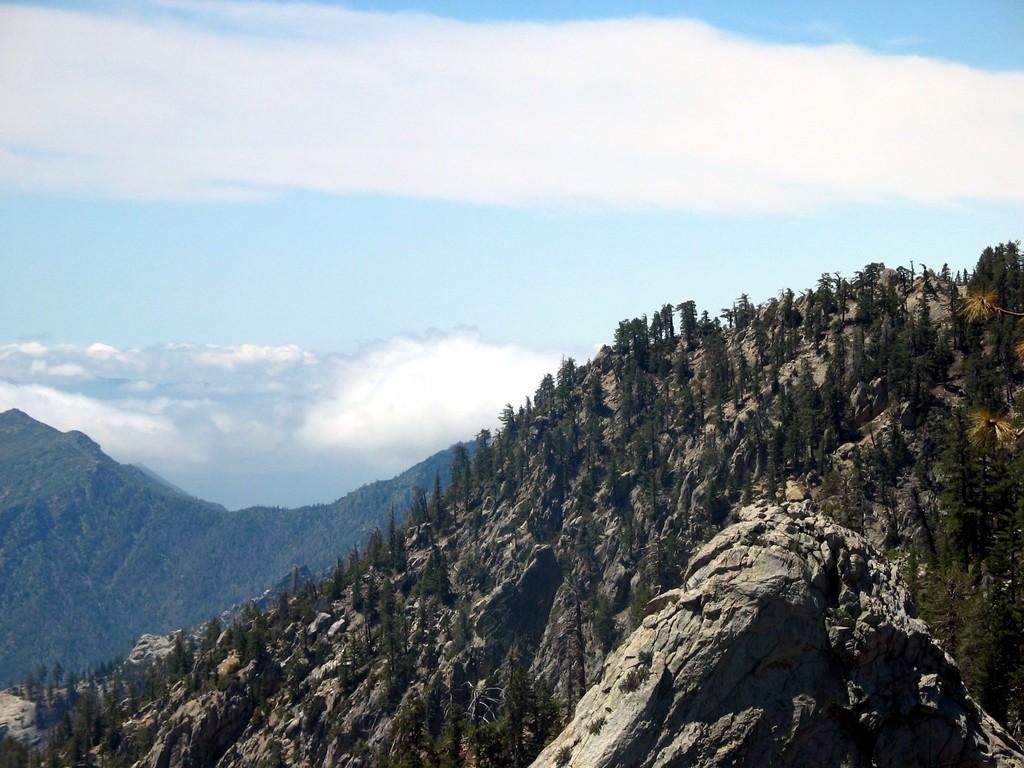Please provide a concise description of this image. In this picture we can see trees and hills. In the background of the image we can see the sky with clouds. 